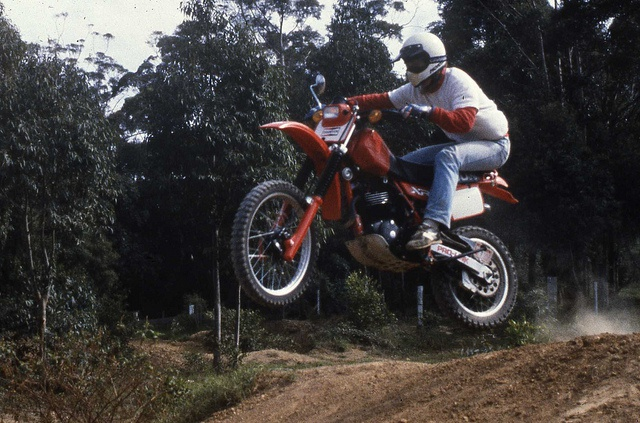Describe the objects in this image and their specific colors. I can see motorcycle in lightgray, black, gray, and maroon tones and people in lightgray, gray, black, and darkgray tones in this image. 